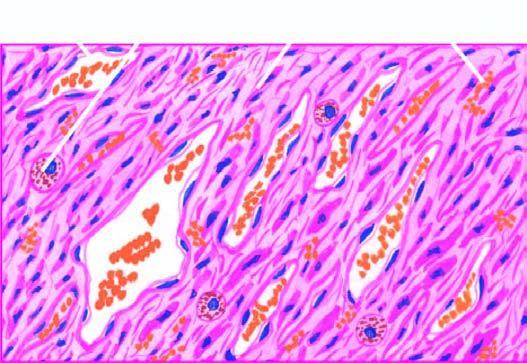re there slit-like blood-filled vascular spaces?
Answer the question using a single word or phrase. Yes 